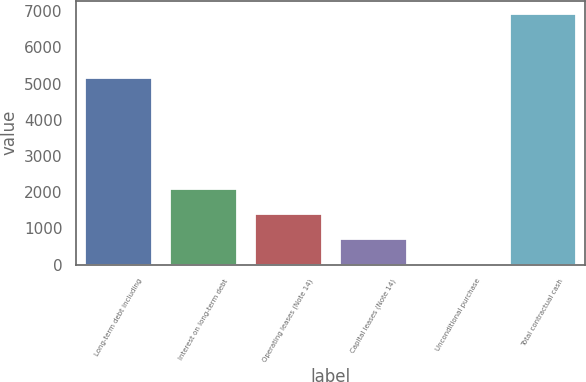<chart> <loc_0><loc_0><loc_500><loc_500><bar_chart><fcel>Long-term debt including<fcel>Interest on long-term debt<fcel>Operating leases (Note 14)<fcel>Capital leases (Note 14)<fcel>Unconditional purchase<fcel>Total contractual cash<nl><fcel>5191<fcel>2105.2<fcel>1413.8<fcel>722.4<fcel>31<fcel>6945<nl></chart> 